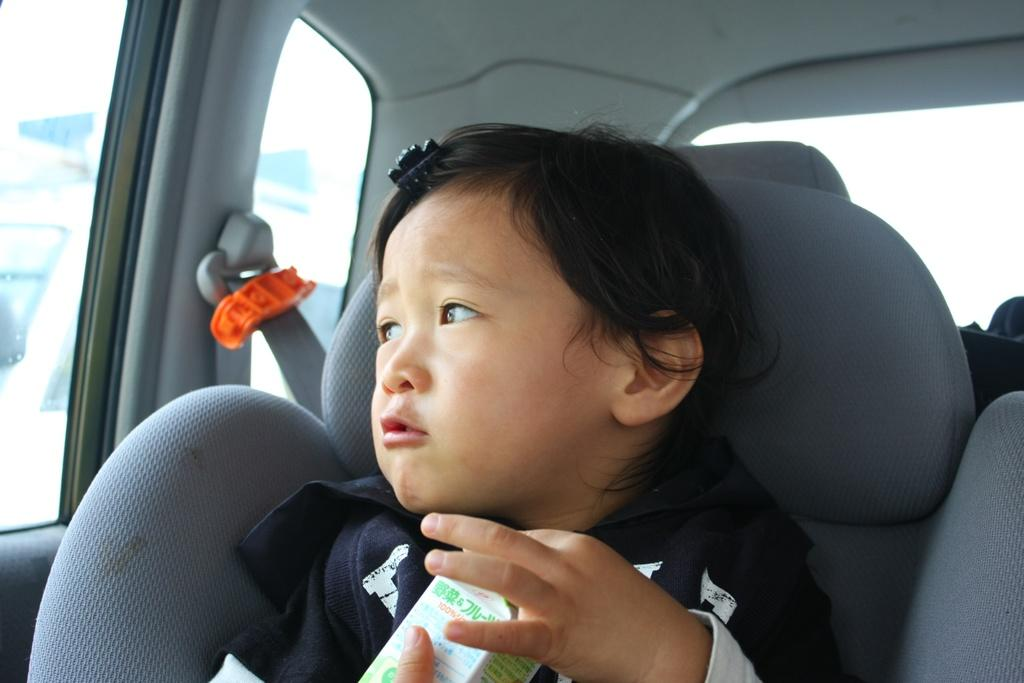What is the setting of the image? The image is an inside view of a car. Can you describe the person in the car? There is a baby in the car. What is the baby wearing? The baby is wearing a blue dress. Where is the baby sitting in the car? The baby is sitting on a seat. What is the baby holding in their hands? The baby is holding a bottle. In which direction is the baby looking? The baby is looking towards the left side. What type of flag can be seen waving outside the car window in the image? There is no flag visible outside the car window in the image. 